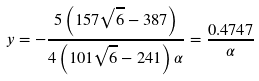Convert formula to latex. <formula><loc_0><loc_0><loc_500><loc_500>y = - \frac { 5 \left ( 1 5 7 \sqrt { 6 } - 3 8 7 \right ) } { 4 \left ( 1 0 1 \sqrt { 6 } - 2 4 1 \right ) \alpha } = \frac { 0 . 4 7 4 7 } { \alpha }</formula> 